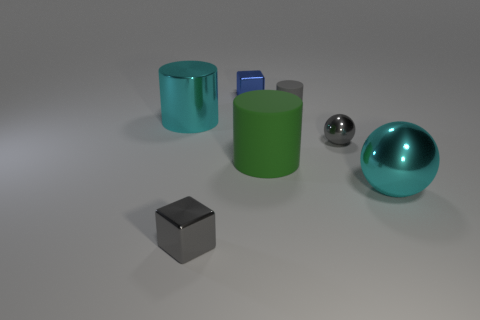Are there any big cyan shiny things to the right of the big ball?
Your answer should be compact. No. The cylinder that is the same color as the big shiny ball is what size?
Your answer should be very brief. Large. Is there a blue object made of the same material as the small ball?
Give a very brief answer. Yes. What color is the small cylinder?
Keep it short and to the point. Gray. There is a gray object that is behind the large metal cylinder; is its shape the same as the green matte object?
Provide a short and direct response. Yes. What shape is the large cyan object in front of the cyan metal object that is to the left of the cylinder to the right of the green matte object?
Make the answer very short. Sphere. There is a small sphere that is behind the green cylinder; what is its material?
Give a very brief answer. Metal. There is a sphere that is the same size as the gray cube; what is its color?
Give a very brief answer. Gray. How many other things are the same shape as the small gray matte object?
Make the answer very short. 2. Is the cyan ball the same size as the green cylinder?
Provide a short and direct response. Yes. 